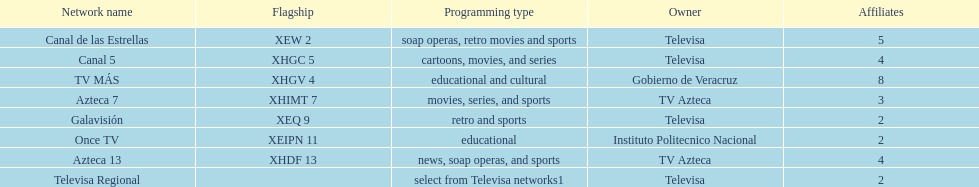How many networks have more affiliates than canal de las estrellas? 1. 